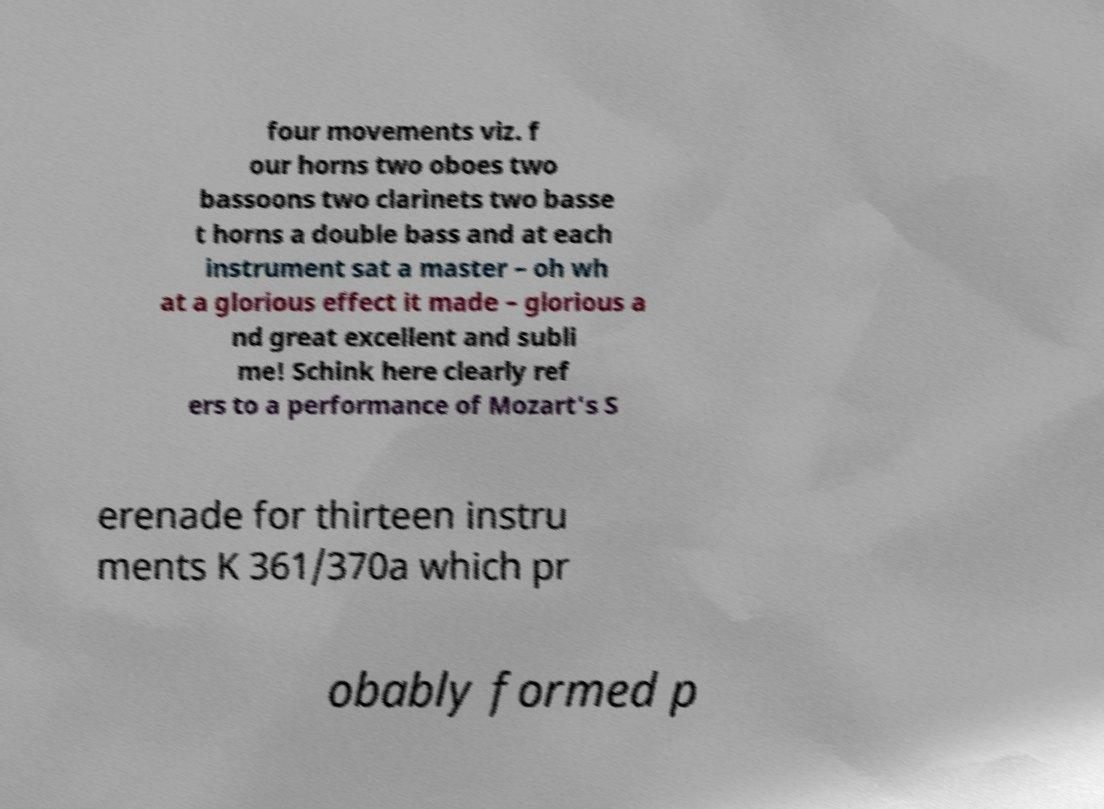I need the written content from this picture converted into text. Can you do that? four movements viz. f our horns two oboes two bassoons two clarinets two basse t horns a double bass and at each instrument sat a master – oh wh at a glorious effect it made – glorious a nd great excellent and subli me! Schink here clearly ref ers to a performance of Mozart's S erenade for thirteen instru ments K 361/370a which pr obably formed p 